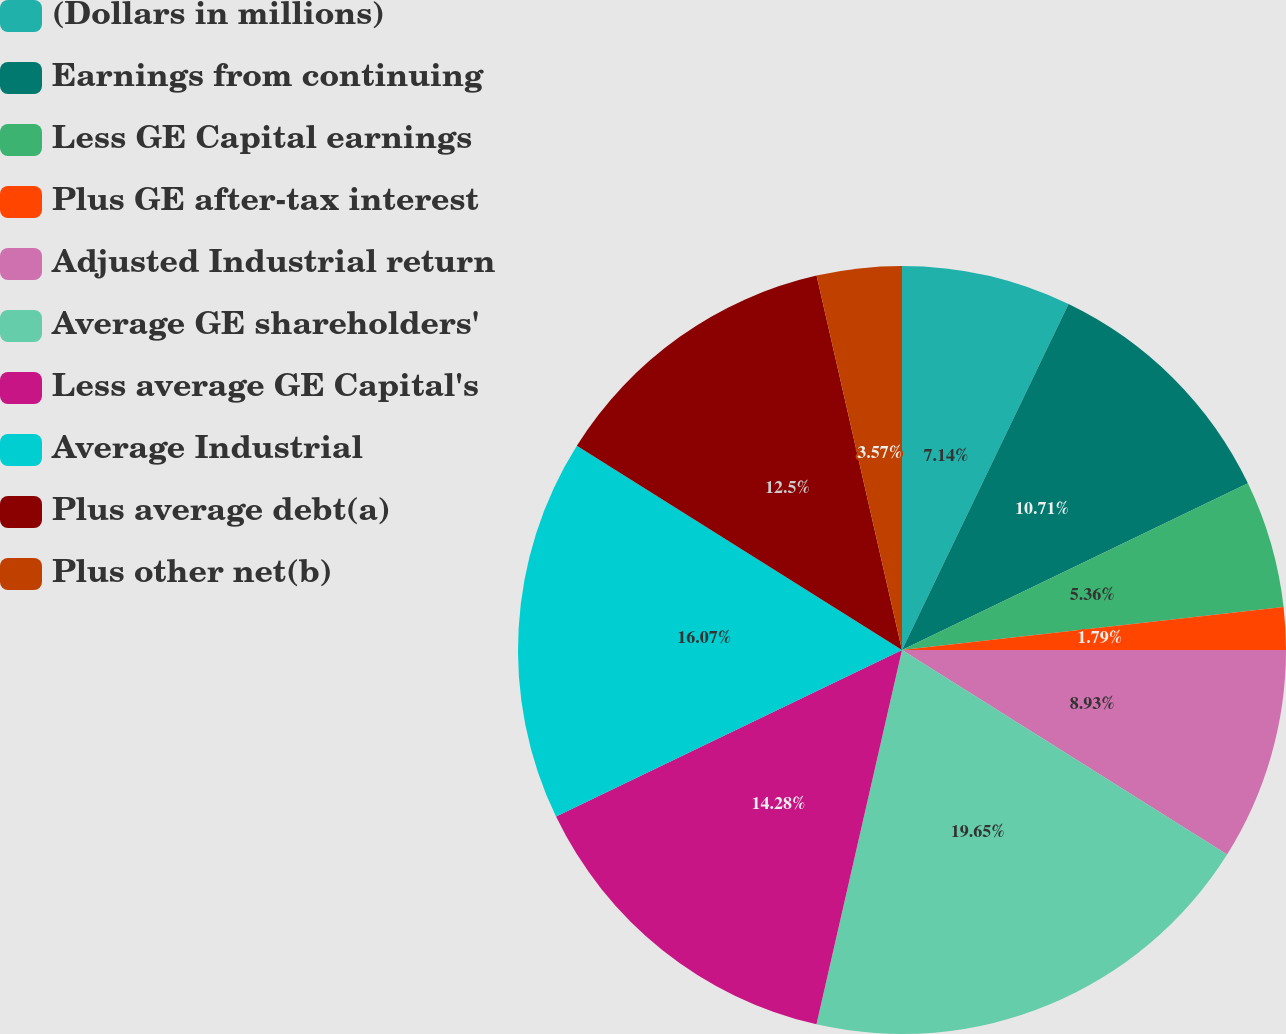Convert chart. <chart><loc_0><loc_0><loc_500><loc_500><pie_chart><fcel>(Dollars in millions)<fcel>Earnings from continuing<fcel>Less GE Capital earnings<fcel>Plus GE after-tax interest<fcel>Adjusted Industrial return<fcel>Average GE shareholders'<fcel>Less average GE Capital's<fcel>Average Industrial<fcel>Plus average debt(a)<fcel>Plus other net(b)<nl><fcel>7.14%<fcel>10.71%<fcel>5.36%<fcel>1.79%<fcel>8.93%<fcel>19.64%<fcel>14.28%<fcel>16.07%<fcel>12.5%<fcel>3.57%<nl></chart> 